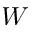Convert formula to latex. <formula><loc_0><loc_0><loc_500><loc_500>W</formula> 